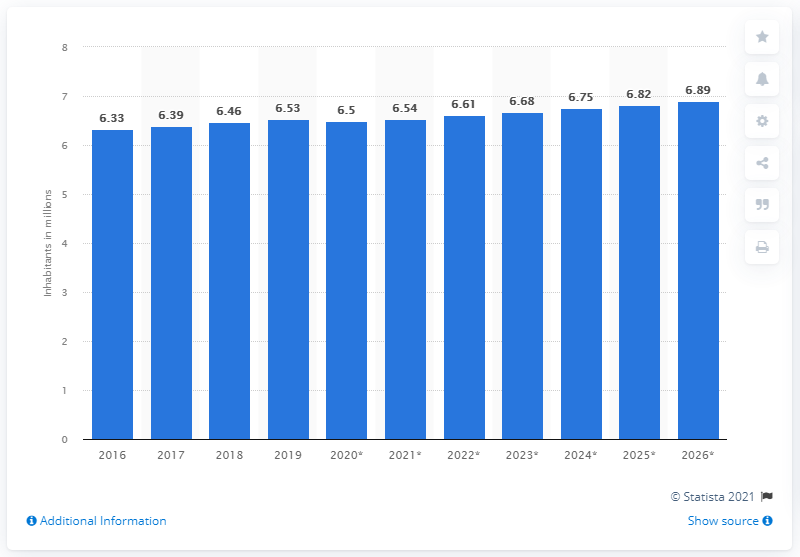List a handful of essential elements in this visual. The population of Nicaragua in 2020 was estimated to be 6.54 million. 